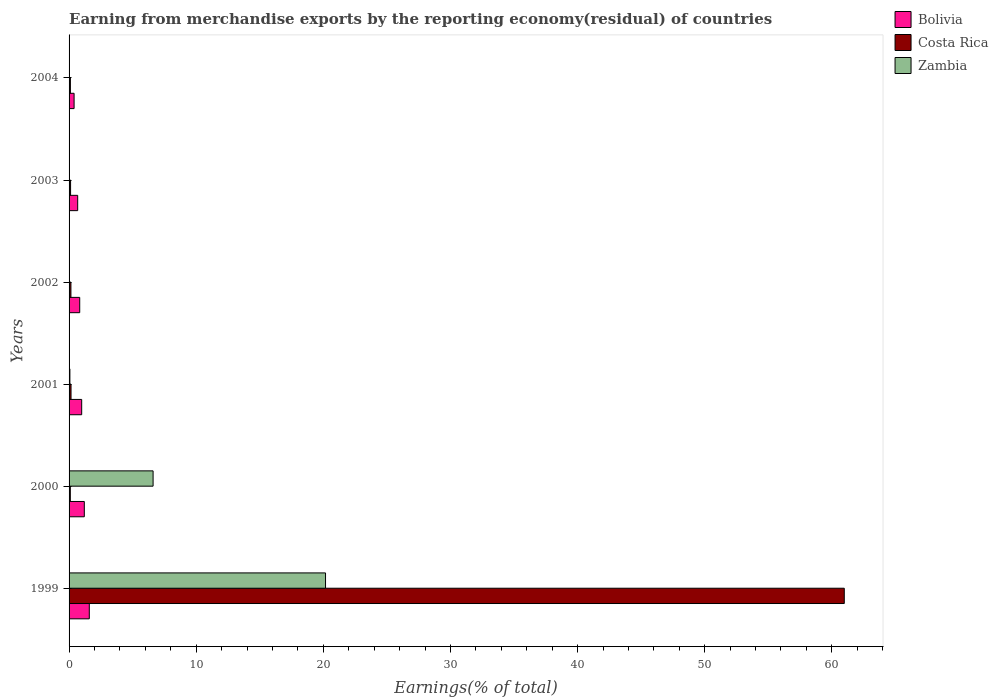How many groups of bars are there?
Make the answer very short. 6. How many bars are there on the 2nd tick from the top?
Provide a short and direct response. 3. How many bars are there on the 3rd tick from the bottom?
Give a very brief answer. 3. In how many cases, is the number of bars for a given year not equal to the number of legend labels?
Provide a succinct answer. 0. What is the percentage of amount earned from merchandise exports in Zambia in 2003?
Your response must be concise. 0. Across all years, what is the maximum percentage of amount earned from merchandise exports in Bolivia?
Provide a succinct answer. 1.59. Across all years, what is the minimum percentage of amount earned from merchandise exports in Bolivia?
Provide a succinct answer. 0.4. In which year was the percentage of amount earned from merchandise exports in Bolivia minimum?
Provide a short and direct response. 2004. What is the total percentage of amount earned from merchandise exports in Costa Rica in the graph?
Give a very brief answer. 61.6. What is the difference between the percentage of amount earned from merchandise exports in Bolivia in 2000 and that in 2004?
Keep it short and to the point. 0.8. What is the difference between the percentage of amount earned from merchandise exports in Zambia in 2000 and the percentage of amount earned from merchandise exports in Bolivia in 2002?
Provide a succinct answer. 5.77. What is the average percentage of amount earned from merchandise exports in Costa Rica per year?
Your response must be concise. 10.27. In the year 2002, what is the difference between the percentage of amount earned from merchandise exports in Costa Rica and percentage of amount earned from merchandise exports in Zambia?
Keep it short and to the point. 0.14. What is the ratio of the percentage of amount earned from merchandise exports in Zambia in 1999 to that in 2001?
Ensure brevity in your answer.  313.18. Is the difference between the percentage of amount earned from merchandise exports in Costa Rica in 1999 and 2002 greater than the difference between the percentage of amount earned from merchandise exports in Zambia in 1999 and 2002?
Your response must be concise. Yes. What is the difference between the highest and the second highest percentage of amount earned from merchandise exports in Costa Rica?
Offer a very short reply. 60.83. What is the difference between the highest and the lowest percentage of amount earned from merchandise exports in Zambia?
Offer a very short reply. 20.17. In how many years, is the percentage of amount earned from merchandise exports in Bolivia greater than the average percentage of amount earned from merchandise exports in Bolivia taken over all years?
Offer a terse response. 3. What does the 3rd bar from the top in 2003 represents?
Your answer should be compact. Bolivia. What does the 1st bar from the bottom in 2000 represents?
Provide a succinct answer. Bolivia. Is it the case that in every year, the sum of the percentage of amount earned from merchandise exports in Zambia and percentage of amount earned from merchandise exports in Bolivia is greater than the percentage of amount earned from merchandise exports in Costa Rica?
Your response must be concise. No. How many bars are there?
Provide a succinct answer. 18. Are all the bars in the graph horizontal?
Your response must be concise. Yes. Are the values on the major ticks of X-axis written in scientific E-notation?
Your response must be concise. No. How many legend labels are there?
Your answer should be very brief. 3. How are the legend labels stacked?
Make the answer very short. Vertical. What is the title of the graph?
Give a very brief answer. Earning from merchandise exports by the reporting economy(residual) of countries. Does "Slovak Republic" appear as one of the legend labels in the graph?
Your response must be concise. No. What is the label or title of the X-axis?
Your answer should be compact. Earnings(% of total). What is the label or title of the Y-axis?
Provide a short and direct response. Years. What is the Earnings(% of total) in Bolivia in 1999?
Provide a succinct answer. 1.59. What is the Earnings(% of total) in Costa Rica in 1999?
Make the answer very short. 60.98. What is the Earnings(% of total) of Zambia in 1999?
Your answer should be very brief. 20.17. What is the Earnings(% of total) in Bolivia in 2000?
Offer a terse response. 1.2. What is the Earnings(% of total) of Costa Rica in 2000?
Your answer should be compact. 0.1. What is the Earnings(% of total) of Zambia in 2000?
Offer a terse response. 6.61. What is the Earnings(% of total) in Bolivia in 2001?
Give a very brief answer. 0.99. What is the Earnings(% of total) of Costa Rica in 2001?
Provide a short and direct response. 0.15. What is the Earnings(% of total) in Zambia in 2001?
Keep it short and to the point. 0.06. What is the Earnings(% of total) of Bolivia in 2002?
Offer a very short reply. 0.84. What is the Earnings(% of total) of Costa Rica in 2002?
Your answer should be very brief. 0.15. What is the Earnings(% of total) of Zambia in 2002?
Your answer should be very brief. 0. What is the Earnings(% of total) in Bolivia in 2003?
Your answer should be compact. 0.68. What is the Earnings(% of total) in Costa Rica in 2003?
Ensure brevity in your answer.  0.12. What is the Earnings(% of total) in Zambia in 2003?
Your response must be concise. 0. What is the Earnings(% of total) of Bolivia in 2004?
Offer a terse response. 0.4. What is the Earnings(% of total) in Costa Rica in 2004?
Your response must be concise. 0.1. What is the Earnings(% of total) in Zambia in 2004?
Ensure brevity in your answer.  0.01. Across all years, what is the maximum Earnings(% of total) in Bolivia?
Your response must be concise. 1.59. Across all years, what is the maximum Earnings(% of total) of Costa Rica?
Provide a succinct answer. 60.98. Across all years, what is the maximum Earnings(% of total) of Zambia?
Keep it short and to the point. 20.17. Across all years, what is the minimum Earnings(% of total) of Bolivia?
Your response must be concise. 0.4. Across all years, what is the minimum Earnings(% of total) in Costa Rica?
Your response must be concise. 0.1. Across all years, what is the minimum Earnings(% of total) of Zambia?
Keep it short and to the point. 0. What is the total Earnings(% of total) in Bolivia in the graph?
Keep it short and to the point. 5.69. What is the total Earnings(% of total) in Costa Rica in the graph?
Offer a very short reply. 61.6. What is the total Earnings(% of total) in Zambia in the graph?
Give a very brief answer. 26.86. What is the difference between the Earnings(% of total) in Bolivia in 1999 and that in 2000?
Keep it short and to the point. 0.39. What is the difference between the Earnings(% of total) of Costa Rica in 1999 and that in 2000?
Provide a succinct answer. 60.88. What is the difference between the Earnings(% of total) of Zambia in 1999 and that in 2000?
Your answer should be compact. 13.56. What is the difference between the Earnings(% of total) of Bolivia in 1999 and that in 2001?
Ensure brevity in your answer.  0.6. What is the difference between the Earnings(% of total) of Costa Rica in 1999 and that in 2001?
Give a very brief answer. 60.83. What is the difference between the Earnings(% of total) of Zambia in 1999 and that in 2001?
Your answer should be very brief. 20.11. What is the difference between the Earnings(% of total) in Bolivia in 1999 and that in 2002?
Make the answer very short. 0.75. What is the difference between the Earnings(% of total) of Costa Rica in 1999 and that in 2002?
Give a very brief answer. 60.83. What is the difference between the Earnings(% of total) in Zambia in 1999 and that in 2002?
Offer a very short reply. 20.17. What is the difference between the Earnings(% of total) of Bolivia in 1999 and that in 2003?
Ensure brevity in your answer.  0.91. What is the difference between the Earnings(% of total) of Costa Rica in 1999 and that in 2003?
Keep it short and to the point. 60.86. What is the difference between the Earnings(% of total) in Zambia in 1999 and that in 2003?
Your answer should be very brief. 20.17. What is the difference between the Earnings(% of total) in Bolivia in 1999 and that in 2004?
Provide a succinct answer. 1.2. What is the difference between the Earnings(% of total) of Costa Rica in 1999 and that in 2004?
Your response must be concise. 60.88. What is the difference between the Earnings(% of total) of Zambia in 1999 and that in 2004?
Your answer should be very brief. 20.17. What is the difference between the Earnings(% of total) in Bolivia in 2000 and that in 2001?
Your response must be concise. 0.21. What is the difference between the Earnings(% of total) in Costa Rica in 2000 and that in 2001?
Your answer should be compact. -0.06. What is the difference between the Earnings(% of total) in Zambia in 2000 and that in 2001?
Your answer should be very brief. 6.55. What is the difference between the Earnings(% of total) in Bolivia in 2000 and that in 2002?
Provide a short and direct response. 0.36. What is the difference between the Earnings(% of total) in Costa Rica in 2000 and that in 2002?
Make the answer very short. -0.05. What is the difference between the Earnings(% of total) in Zambia in 2000 and that in 2002?
Provide a short and direct response. 6.61. What is the difference between the Earnings(% of total) in Bolivia in 2000 and that in 2003?
Keep it short and to the point. 0.52. What is the difference between the Earnings(% of total) in Costa Rica in 2000 and that in 2003?
Offer a terse response. -0.02. What is the difference between the Earnings(% of total) of Zambia in 2000 and that in 2003?
Provide a succinct answer. 6.61. What is the difference between the Earnings(% of total) in Bolivia in 2000 and that in 2004?
Offer a terse response. 0.8. What is the difference between the Earnings(% of total) in Costa Rica in 2000 and that in 2004?
Your answer should be very brief. -0.01. What is the difference between the Earnings(% of total) in Zambia in 2000 and that in 2004?
Give a very brief answer. 6.6. What is the difference between the Earnings(% of total) in Bolivia in 2001 and that in 2002?
Make the answer very short. 0.15. What is the difference between the Earnings(% of total) in Costa Rica in 2001 and that in 2002?
Provide a short and direct response. 0.01. What is the difference between the Earnings(% of total) in Zambia in 2001 and that in 2002?
Your answer should be very brief. 0.06. What is the difference between the Earnings(% of total) of Bolivia in 2001 and that in 2003?
Keep it short and to the point. 0.31. What is the difference between the Earnings(% of total) in Costa Rica in 2001 and that in 2003?
Provide a short and direct response. 0.04. What is the difference between the Earnings(% of total) of Zambia in 2001 and that in 2003?
Provide a short and direct response. 0.06. What is the difference between the Earnings(% of total) in Bolivia in 2001 and that in 2004?
Your answer should be very brief. 0.6. What is the difference between the Earnings(% of total) in Costa Rica in 2001 and that in 2004?
Give a very brief answer. 0.05. What is the difference between the Earnings(% of total) in Zambia in 2001 and that in 2004?
Your response must be concise. 0.06. What is the difference between the Earnings(% of total) in Bolivia in 2002 and that in 2003?
Your answer should be very brief. 0.16. What is the difference between the Earnings(% of total) of Costa Rica in 2002 and that in 2003?
Provide a succinct answer. 0.03. What is the difference between the Earnings(% of total) of Zambia in 2002 and that in 2003?
Your answer should be very brief. -0. What is the difference between the Earnings(% of total) in Bolivia in 2002 and that in 2004?
Provide a short and direct response. 0.44. What is the difference between the Earnings(% of total) in Costa Rica in 2002 and that in 2004?
Ensure brevity in your answer.  0.04. What is the difference between the Earnings(% of total) of Zambia in 2002 and that in 2004?
Ensure brevity in your answer.  -0.01. What is the difference between the Earnings(% of total) of Bolivia in 2003 and that in 2004?
Make the answer very short. 0.28. What is the difference between the Earnings(% of total) in Costa Rica in 2003 and that in 2004?
Provide a short and direct response. 0.02. What is the difference between the Earnings(% of total) in Zambia in 2003 and that in 2004?
Ensure brevity in your answer.  -0. What is the difference between the Earnings(% of total) in Bolivia in 1999 and the Earnings(% of total) in Costa Rica in 2000?
Give a very brief answer. 1.49. What is the difference between the Earnings(% of total) of Bolivia in 1999 and the Earnings(% of total) of Zambia in 2000?
Your response must be concise. -5.02. What is the difference between the Earnings(% of total) in Costa Rica in 1999 and the Earnings(% of total) in Zambia in 2000?
Offer a very short reply. 54.37. What is the difference between the Earnings(% of total) in Bolivia in 1999 and the Earnings(% of total) in Costa Rica in 2001?
Your response must be concise. 1.44. What is the difference between the Earnings(% of total) in Bolivia in 1999 and the Earnings(% of total) in Zambia in 2001?
Keep it short and to the point. 1.53. What is the difference between the Earnings(% of total) of Costa Rica in 1999 and the Earnings(% of total) of Zambia in 2001?
Make the answer very short. 60.92. What is the difference between the Earnings(% of total) of Bolivia in 1999 and the Earnings(% of total) of Costa Rica in 2002?
Your response must be concise. 1.45. What is the difference between the Earnings(% of total) of Bolivia in 1999 and the Earnings(% of total) of Zambia in 2002?
Keep it short and to the point. 1.59. What is the difference between the Earnings(% of total) in Costa Rica in 1999 and the Earnings(% of total) in Zambia in 2002?
Give a very brief answer. 60.98. What is the difference between the Earnings(% of total) in Bolivia in 1999 and the Earnings(% of total) in Costa Rica in 2003?
Offer a very short reply. 1.47. What is the difference between the Earnings(% of total) in Bolivia in 1999 and the Earnings(% of total) in Zambia in 2003?
Your response must be concise. 1.59. What is the difference between the Earnings(% of total) in Costa Rica in 1999 and the Earnings(% of total) in Zambia in 2003?
Your answer should be compact. 60.98. What is the difference between the Earnings(% of total) in Bolivia in 1999 and the Earnings(% of total) in Costa Rica in 2004?
Give a very brief answer. 1.49. What is the difference between the Earnings(% of total) in Bolivia in 1999 and the Earnings(% of total) in Zambia in 2004?
Give a very brief answer. 1.58. What is the difference between the Earnings(% of total) in Costa Rica in 1999 and the Earnings(% of total) in Zambia in 2004?
Your answer should be compact. 60.97. What is the difference between the Earnings(% of total) of Bolivia in 2000 and the Earnings(% of total) of Costa Rica in 2001?
Provide a succinct answer. 1.04. What is the difference between the Earnings(% of total) in Bolivia in 2000 and the Earnings(% of total) in Zambia in 2001?
Your response must be concise. 1.13. What is the difference between the Earnings(% of total) in Costa Rica in 2000 and the Earnings(% of total) in Zambia in 2001?
Ensure brevity in your answer.  0.03. What is the difference between the Earnings(% of total) of Bolivia in 2000 and the Earnings(% of total) of Costa Rica in 2002?
Offer a very short reply. 1.05. What is the difference between the Earnings(% of total) of Bolivia in 2000 and the Earnings(% of total) of Zambia in 2002?
Give a very brief answer. 1.2. What is the difference between the Earnings(% of total) in Costa Rica in 2000 and the Earnings(% of total) in Zambia in 2002?
Your answer should be very brief. 0.1. What is the difference between the Earnings(% of total) of Bolivia in 2000 and the Earnings(% of total) of Costa Rica in 2003?
Your answer should be compact. 1.08. What is the difference between the Earnings(% of total) in Bolivia in 2000 and the Earnings(% of total) in Zambia in 2003?
Ensure brevity in your answer.  1.2. What is the difference between the Earnings(% of total) of Costa Rica in 2000 and the Earnings(% of total) of Zambia in 2003?
Provide a short and direct response. 0.09. What is the difference between the Earnings(% of total) in Bolivia in 2000 and the Earnings(% of total) in Costa Rica in 2004?
Offer a terse response. 1.09. What is the difference between the Earnings(% of total) in Bolivia in 2000 and the Earnings(% of total) in Zambia in 2004?
Offer a very short reply. 1.19. What is the difference between the Earnings(% of total) of Costa Rica in 2000 and the Earnings(% of total) of Zambia in 2004?
Give a very brief answer. 0.09. What is the difference between the Earnings(% of total) of Bolivia in 2001 and the Earnings(% of total) of Costa Rica in 2002?
Your answer should be compact. 0.85. What is the difference between the Earnings(% of total) of Bolivia in 2001 and the Earnings(% of total) of Zambia in 2002?
Your answer should be very brief. 0.99. What is the difference between the Earnings(% of total) of Costa Rica in 2001 and the Earnings(% of total) of Zambia in 2002?
Offer a terse response. 0.15. What is the difference between the Earnings(% of total) in Bolivia in 2001 and the Earnings(% of total) in Costa Rica in 2003?
Offer a very short reply. 0.87. What is the difference between the Earnings(% of total) of Bolivia in 2001 and the Earnings(% of total) of Zambia in 2003?
Ensure brevity in your answer.  0.99. What is the difference between the Earnings(% of total) of Costa Rica in 2001 and the Earnings(% of total) of Zambia in 2003?
Ensure brevity in your answer.  0.15. What is the difference between the Earnings(% of total) of Bolivia in 2001 and the Earnings(% of total) of Costa Rica in 2004?
Your answer should be compact. 0.89. What is the difference between the Earnings(% of total) of Bolivia in 2001 and the Earnings(% of total) of Zambia in 2004?
Your answer should be compact. 0.98. What is the difference between the Earnings(% of total) in Costa Rica in 2001 and the Earnings(% of total) in Zambia in 2004?
Offer a terse response. 0.15. What is the difference between the Earnings(% of total) in Bolivia in 2002 and the Earnings(% of total) in Costa Rica in 2003?
Offer a very short reply. 0.72. What is the difference between the Earnings(% of total) in Bolivia in 2002 and the Earnings(% of total) in Zambia in 2003?
Your response must be concise. 0.83. What is the difference between the Earnings(% of total) of Costa Rica in 2002 and the Earnings(% of total) of Zambia in 2003?
Provide a short and direct response. 0.14. What is the difference between the Earnings(% of total) in Bolivia in 2002 and the Earnings(% of total) in Costa Rica in 2004?
Keep it short and to the point. 0.73. What is the difference between the Earnings(% of total) in Bolivia in 2002 and the Earnings(% of total) in Zambia in 2004?
Your response must be concise. 0.83. What is the difference between the Earnings(% of total) in Costa Rica in 2002 and the Earnings(% of total) in Zambia in 2004?
Provide a short and direct response. 0.14. What is the difference between the Earnings(% of total) of Bolivia in 2003 and the Earnings(% of total) of Costa Rica in 2004?
Give a very brief answer. 0.57. What is the difference between the Earnings(% of total) of Bolivia in 2003 and the Earnings(% of total) of Zambia in 2004?
Ensure brevity in your answer.  0.67. What is the difference between the Earnings(% of total) in Costa Rica in 2003 and the Earnings(% of total) in Zambia in 2004?
Give a very brief answer. 0.11. What is the average Earnings(% of total) in Bolivia per year?
Keep it short and to the point. 0.95. What is the average Earnings(% of total) in Costa Rica per year?
Give a very brief answer. 10.27. What is the average Earnings(% of total) of Zambia per year?
Your answer should be compact. 4.48. In the year 1999, what is the difference between the Earnings(% of total) of Bolivia and Earnings(% of total) of Costa Rica?
Offer a terse response. -59.39. In the year 1999, what is the difference between the Earnings(% of total) of Bolivia and Earnings(% of total) of Zambia?
Keep it short and to the point. -18.58. In the year 1999, what is the difference between the Earnings(% of total) in Costa Rica and Earnings(% of total) in Zambia?
Give a very brief answer. 40.81. In the year 2000, what is the difference between the Earnings(% of total) in Bolivia and Earnings(% of total) in Costa Rica?
Your answer should be very brief. 1.1. In the year 2000, what is the difference between the Earnings(% of total) of Bolivia and Earnings(% of total) of Zambia?
Your response must be concise. -5.41. In the year 2000, what is the difference between the Earnings(% of total) in Costa Rica and Earnings(% of total) in Zambia?
Keep it short and to the point. -6.51. In the year 2001, what is the difference between the Earnings(% of total) in Bolivia and Earnings(% of total) in Costa Rica?
Your answer should be compact. 0.84. In the year 2001, what is the difference between the Earnings(% of total) in Bolivia and Earnings(% of total) in Zambia?
Your answer should be compact. 0.93. In the year 2001, what is the difference between the Earnings(% of total) of Costa Rica and Earnings(% of total) of Zambia?
Provide a short and direct response. 0.09. In the year 2002, what is the difference between the Earnings(% of total) in Bolivia and Earnings(% of total) in Costa Rica?
Provide a short and direct response. 0.69. In the year 2002, what is the difference between the Earnings(% of total) in Bolivia and Earnings(% of total) in Zambia?
Your answer should be very brief. 0.84. In the year 2002, what is the difference between the Earnings(% of total) of Costa Rica and Earnings(% of total) of Zambia?
Your answer should be compact. 0.14. In the year 2003, what is the difference between the Earnings(% of total) of Bolivia and Earnings(% of total) of Costa Rica?
Your response must be concise. 0.56. In the year 2003, what is the difference between the Earnings(% of total) of Bolivia and Earnings(% of total) of Zambia?
Keep it short and to the point. 0.68. In the year 2003, what is the difference between the Earnings(% of total) of Costa Rica and Earnings(% of total) of Zambia?
Provide a short and direct response. 0.12. In the year 2004, what is the difference between the Earnings(% of total) in Bolivia and Earnings(% of total) in Costa Rica?
Keep it short and to the point. 0.29. In the year 2004, what is the difference between the Earnings(% of total) in Bolivia and Earnings(% of total) in Zambia?
Your answer should be compact. 0.39. In the year 2004, what is the difference between the Earnings(% of total) in Costa Rica and Earnings(% of total) in Zambia?
Keep it short and to the point. 0.1. What is the ratio of the Earnings(% of total) in Bolivia in 1999 to that in 2000?
Give a very brief answer. 1.33. What is the ratio of the Earnings(% of total) of Costa Rica in 1999 to that in 2000?
Provide a short and direct response. 624.83. What is the ratio of the Earnings(% of total) in Zambia in 1999 to that in 2000?
Provide a succinct answer. 3.05. What is the ratio of the Earnings(% of total) in Bolivia in 1999 to that in 2001?
Offer a terse response. 1.6. What is the ratio of the Earnings(% of total) of Costa Rica in 1999 to that in 2001?
Provide a short and direct response. 396.09. What is the ratio of the Earnings(% of total) in Zambia in 1999 to that in 2001?
Provide a succinct answer. 313.18. What is the ratio of the Earnings(% of total) of Bolivia in 1999 to that in 2002?
Keep it short and to the point. 1.9. What is the ratio of the Earnings(% of total) of Costa Rica in 1999 to that in 2002?
Make the answer very short. 419.06. What is the ratio of the Earnings(% of total) in Zambia in 1999 to that in 2002?
Your answer should be very brief. 1.22e+04. What is the ratio of the Earnings(% of total) in Bolivia in 1999 to that in 2003?
Keep it short and to the point. 2.35. What is the ratio of the Earnings(% of total) in Costa Rica in 1999 to that in 2003?
Offer a terse response. 512.97. What is the ratio of the Earnings(% of total) in Zambia in 1999 to that in 2003?
Your answer should be compact. 7053.05. What is the ratio of the Earnings(% of total) of Bolivia in 1999 to that in 2004?
Provide a succinct answer. 4.02. What is the ratio of the Earnings(% of total) in Costa Rica in 1999 to that in 2004?
Make the answer very short. 587.73. What is the ratio of the Earnings(% of total) in Zambia in 1999 to that in 2004?
Provide a succinct answer. 2655.88. What is the ratio of the Earnings(% of total) in Bolivia in 2000 to that in 2001?
Provide a short and direct response. 1.21. What is the ratio of the Earnings(% of total) in Costa Rica in 2000 to that in 2001?
Keep it short and to the point. 0.63. What is the ratio of the Earnings(% of total) of Zambia in 2000 to that in 2001?
Ensure brevity in your answer.  102.61. What is the ratio of the Earnings(% of total) of Bolivia in 2000 to that in 2002?
Make the answer very short. 1.43. What is the ratio of the Earnings(% of total) of Costa Rica in 2000 to that in 2002?
Your response must be concise. 0.67. What is the ratio of the Earnings(% of total) of Zambia in 2000 to that in 2002?
Offer a very short reply. 3982.34. What is the ratio of the Earnings(% of total) of Bolivia in 2000 to that in 2003?
Offer a very short reply. 1.77. What is the ratio of the Earnings(% of total) of Costa Rica in 2000 to that in 2003?
Provide a succinct answer. 0.82. What is the ratio of the Earnings(% of total) in Zambia in 2000 to that in 2003?
Keep it short and to the point. 2310.88. What is the ratio of the Earnings(% of total) of Bolivia in 2000 to that in 2004?
Offer a very short reply. 3.03. What is the ratio of the Earnings(% of total) of Costa Rica in 2000 to that in 2004?
Provide a short and direct response. 0.94. What is the ratio of the Earnings(% of total) of Zambia in 2000 to that in 2004?
Provide a short and direct response. 870.18. What is the ratio of the Earnings(% of total) in Bolivia in 2001 to that in 2002?
Make the answer very short. 1.18. What is the ratio of the Earnings(% of total) in Costa Rica in 2001 to that in 2002?
Offer a very short reply. 1.06. What is the ratio of the Earnings(% of total) in Zambia in 2001 to that in 2002?
Offer a very short reply. 38.81. What is the ratio of the Earnings(% of total) in Bolivia in 2001 to that in 2003?
Provide a succinct answer. 1.46. What is the ratio of the Earnings(% of total) in Costa Rica in 2001 to that in 2003?
Your answer should be very brief. 1.3. What is the ratio of the Earnings(% of total) of Zambia in 2001 to that in 2003?
Your answer should be compact. 22.52. What is the ratio of the Earnings(% of total) in Bolivia in 2001 to that in 2004?
Ensure brevity in your answer.  2.51. What is the ratio of the Earnings(% of total) of Costa Rica in 2001 to that in 2004?
Keep it short and to the point. 1.48. What is the ratio of the Earnings(% of total) of Zambia in 2001 to that in 2004?
Provide a short and direct response. 8.48. What is the ratio of the Earnings(% of total) of Bolivia in 2002 to that in 2003?
Ensure brevity in your answer.  1.24. What is the ratio of the Earnings(% of total) of Costa Rica in 2002 to that in 2003?
Ensure brevity in your answer.  1.22. What is the ratio of the Earnings(% of total) of Zambia in 2002 to that in 2003?
Offer a terse response. 0.58. What is the ratio of the Earnings(% of total) of Bolivia in 2002 to that in 2004?
Make the answer very short. 2.12. What is the ratio of the Earnings(% of total) of Costa Rica in 2002 to that in 2004?
Make the answer very short. 1.4. What is the ratio of the Earnings(% of total) of Zambia in 2002 to that in 2004?
Keep it short and to the point. 0.22. What is the ratio of the Earnings(% of total) of Bolivia in 2003 to that in 2004?
Provide a short and direct response. 1.71. What is the ratio of the Earnings(% of total) in Costa Rica in 2003 to that in 2004?
Offer a terse response. 1.15. What is the ratio of the Earnings(% of total) in Zambia in 2003 to that in 2004?
Your answer should be very brief. 0.38. What is the difference between the highest and the second highest Earnings(% of total) in Bolivia?
Provide a succinct answer. 0.39. What is the difference between the highest and the second highest Earnings(% of total) of Costa Rica?
Your answer should be very brief. 60.83. What is the difference between the highest and the second highest Earnings(% of total) of Zambia?
Your response must be concise. 13.56. What is the difference between the highest and the lowest Earnings(% of total) of Bolivia?
Offer a very short reply. 1.2. What is the difference between the highest and the lowest Earnings(% of total) in Costa Rica?
Offer a very short reply. 60.88. What is the difference between the highest and the lowest Earnings(% of total) of Zambia?
Offer a very short reply. 20.17. 